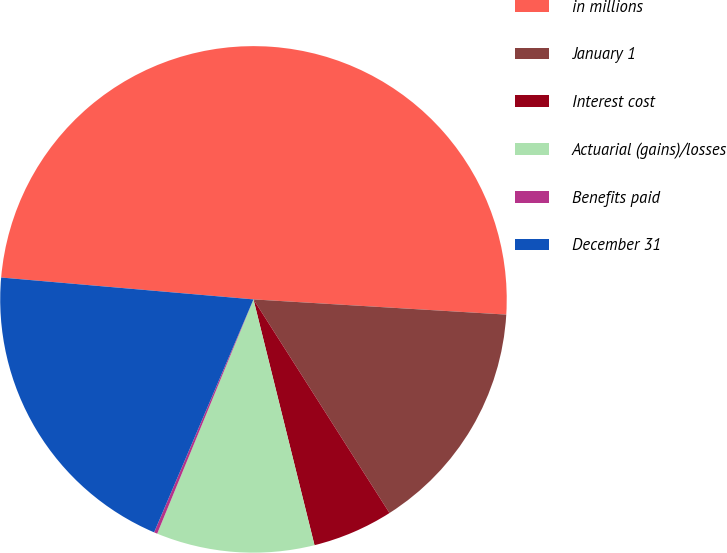<chart> <loc_0><loc_0><loc_500><loc_500><pie_chart><fcel>in millions<fcel>January 1<fcel>Interest cost<fcel>Actuarial (gains)/losses<fcel>Benefits paid<fcel>December 31<nl><fcel>49.58%<fcel>15.02%<fcel>5.15%<fcel>10.08%<fcel>0.21%<fcel>19.96%<nl></chart> 